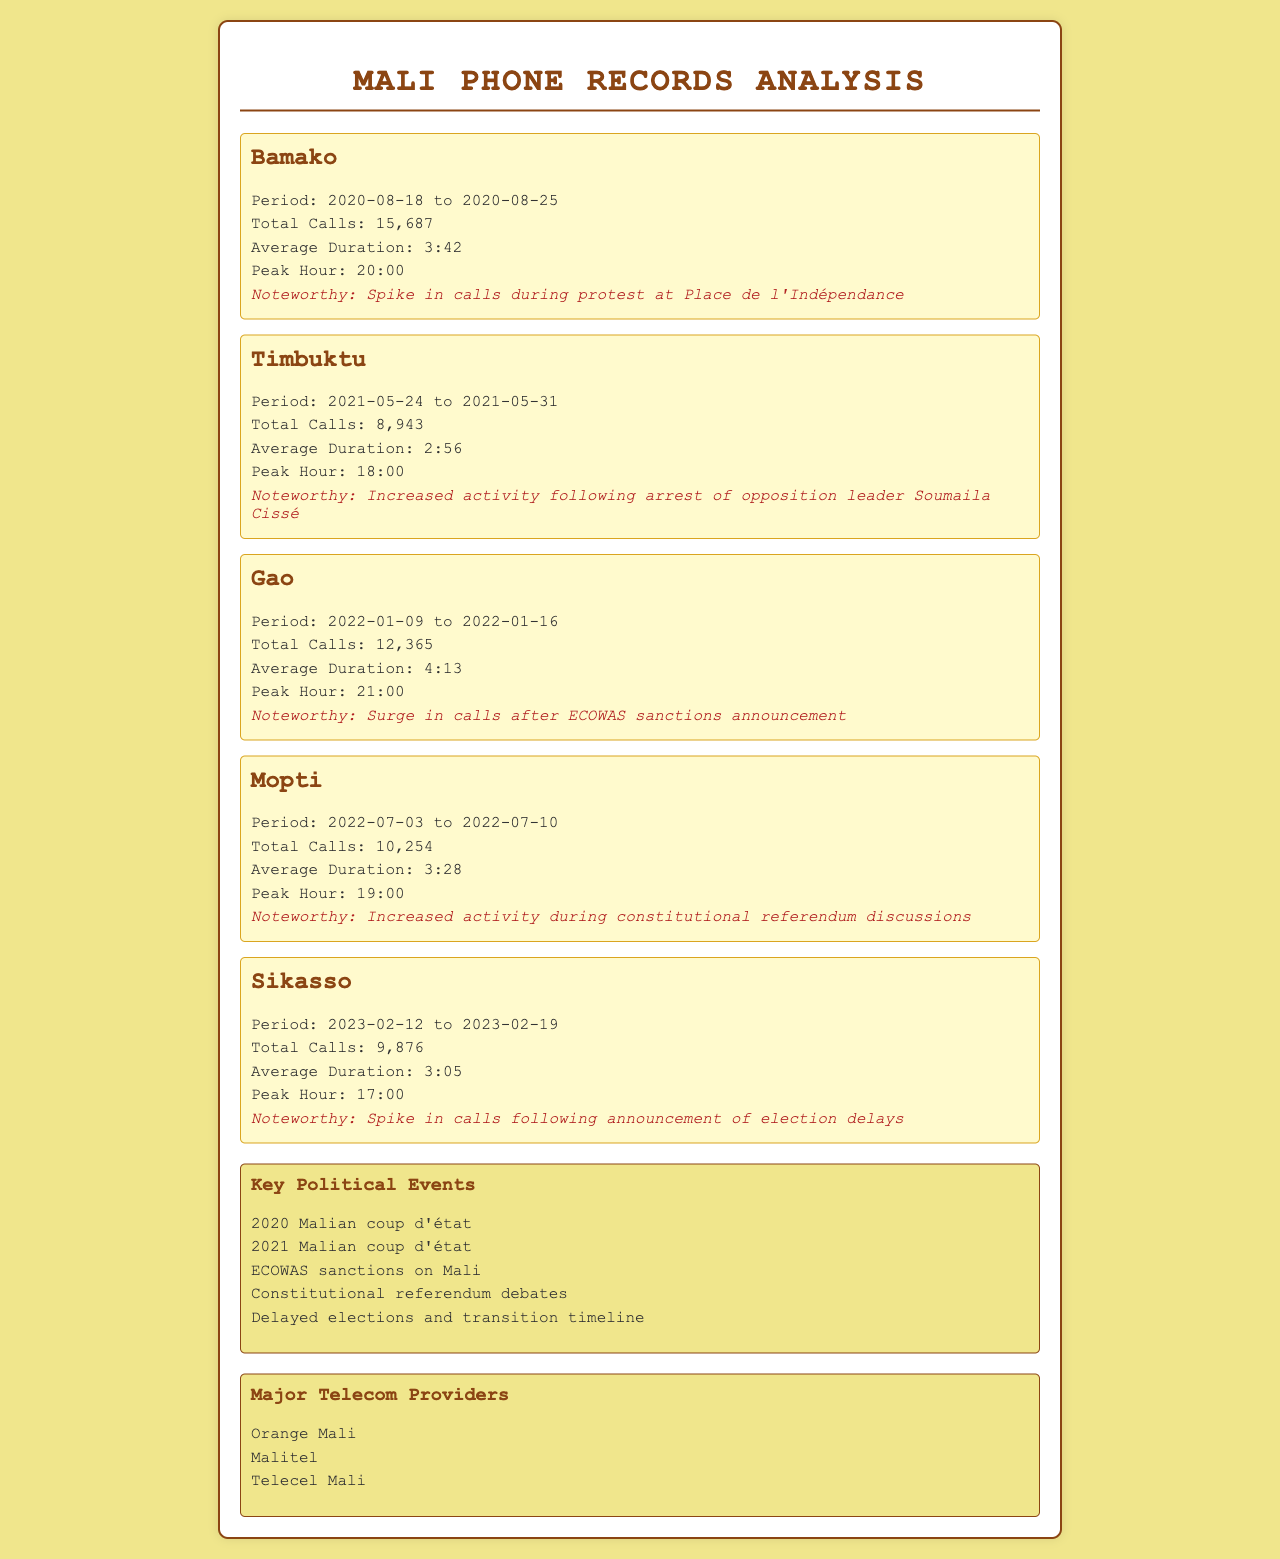what is the total number of calls made in Bamako? The total number of calls made in Bamako is specified in the document as 15,687.
Answer: 15,687 what was the average call duration in Gao? The average call duration in Gao is stated as 4:13.
Answer: 4:13 when did the spike in calls occur in Sikasso? The noteworthy spike in calls in Sikasso occurred following the announcement of election delays.
Answer: election delays what was the peak hour for calls in Timbuktu? The peak hour for calls in Timbuktu is given as 18:00.
Answer: 18:00 how many total calls were recorded during the period in Mopti? The total calls recorded during the period in Mopti is provided as 10,254.
Answer: 10,254 which major telecom provider is mentioned last in the document? The last major telecom provider mentioned in the document is Telecel Mali.
Answer: Telecel Mali what political event led to increased call activity in Gao? The surge in calls in Gao is noted to follow the ECOWAS sanctions announcement.
Answer: ECOWAS sanctions which city had the highest average call duration? The city with the highest average call duration is Gao, with an average of 4:13.
Answer: Gao what date range corresponds to the protests at Place de l'Indépendance in Bamako? The date range corresponding to the protests at Place de l'Indépendance in Bamako is 2020-08-18 to 2020-08-25.
Answer: 2020-08-18 to 2020-08-25 